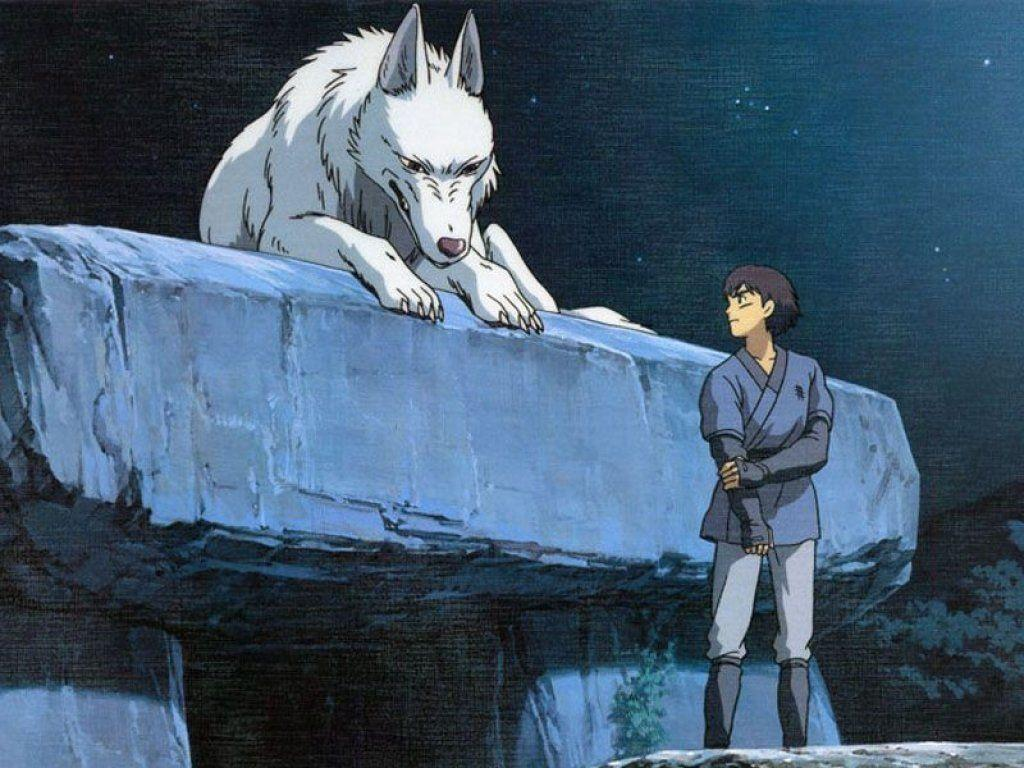What type of image is this? The image is animated. What can be seen on the rock in the image? There is an animal on a rock in the image. Who else is present in the image besides the animal? There is a man in the image. What type of vegetation is in the image? There is a plant in the image. What is visible in the background of the image? The sky is visible in the image, and stars are present in the image. What type of noise does the rail make in the image? There is no rail present in the image, so it is not possible to determine the noise it might make. 